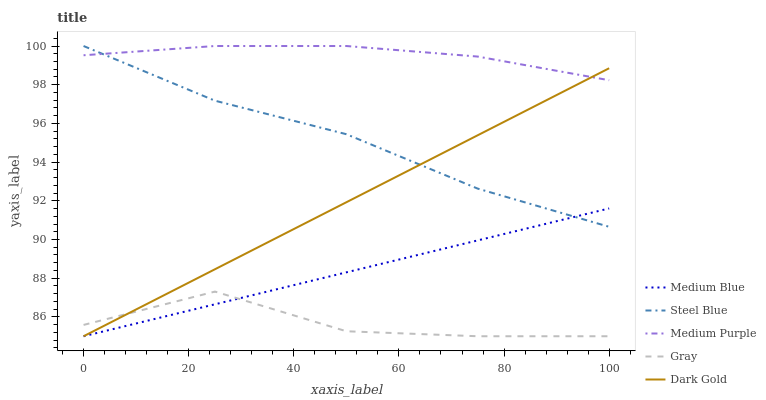Does Medium Blue have the minimum area under the curve?
Answer yes or no. No. Does Medium Blue have the maximum area under the curve?
Answer yes or no. No. Is Gray the smoothest?
Answer yes or no. No. Is Medium Blue the roughest?
Answer yes or no. No. Does Steel Blue have the lowest value?
Answer yes or no. No. Does Medium Blue have the highest value?
Answer yes or no. No. Is Medium Blue less than Medium Purple?
Answer yes or no. Yes. Is Medium Purple greater than Gray?
Answer yes or no. Yes. Does Medium Blue intersect Medium Purple?
Answer yes or no. No. 